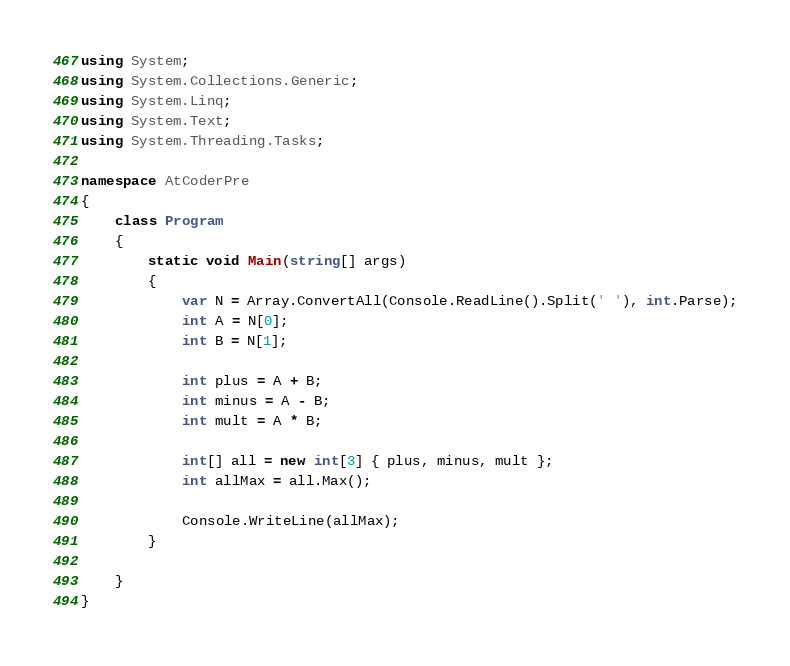<code> <loc_0><loc_0><loc_500><loc_500><_C#_>using System;
using System.Collections.Generic;
using System.Linq;
using System.Text;
using System.Threading.Tasks;

namespace AtCoderPre
{
    class Program
    {
        static void Main(string[] args)
        {
            var N = Array.ConvertAll(Console.ReadLine().Split(' '), int.Parse);
            int A = N[0];
            int B = N[1];

            int plus = A + B;
            int minus = A - B;
            int mult = A * B;

            int[] all = new int[3] { plus, minus, mult };
            int allMax = all.Max();

            Console.WriteLine(allMax);
        }

    }
}

</code> 